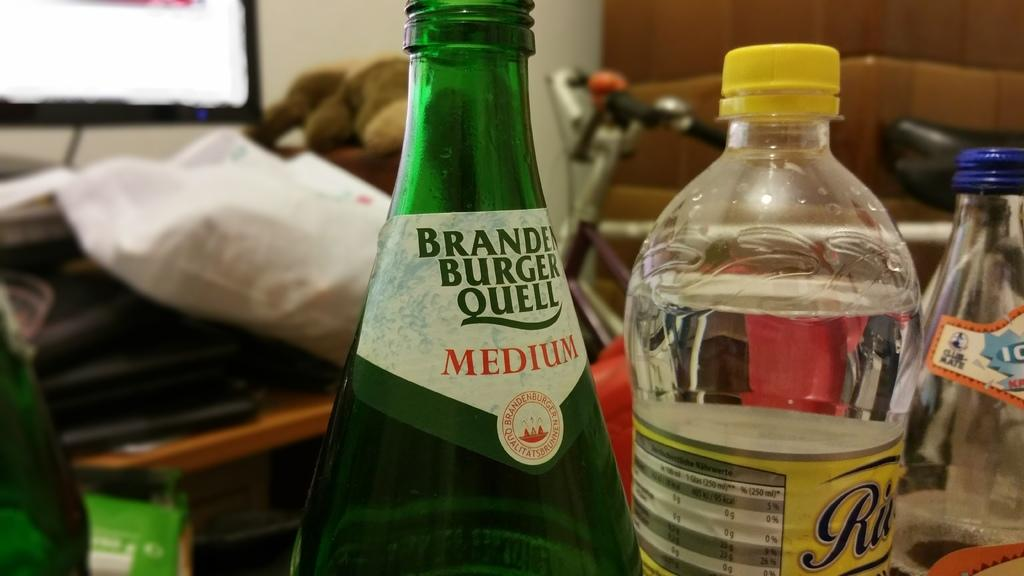<image>
Provide a brief description of the given image. A medium green glass bottle sits next to a plastic bottle with a yellow cap. 